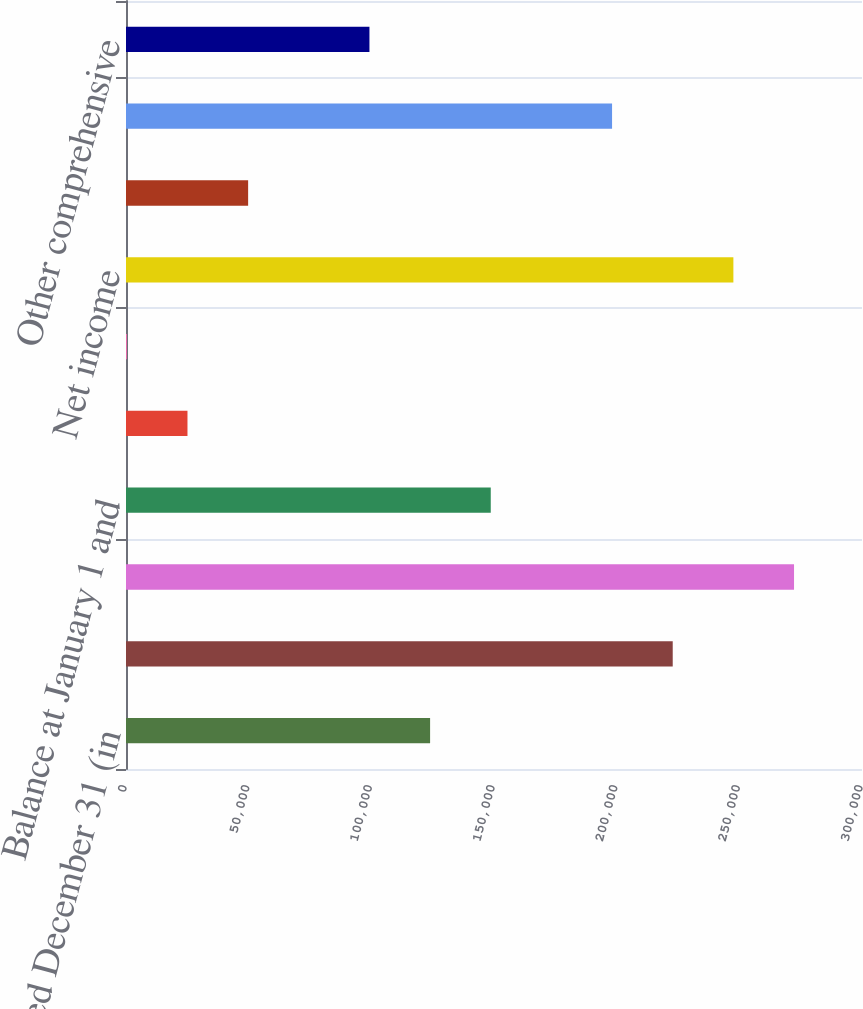<chart> <loc_0><loc_0><loc_500><loc_500><bar_chart><fcel>Year ended December 31 (in<fcel>Balance at January 1<fcel>Balance at December 31<fcel>Balance at January 1 and<fcel>Shares issued and commitments<fcel>Other<fcel>Net income<fcel>Preferred stock<fcel>Common stock ( 188 172 and 158<fcel>Other comprehensive<nl><fcel>123954<fcel>222849<fcel>272297<fcel>148677<fcel>25057.9<fcel>334<fcel>247573<fcel>49781.8<fcel>198125<fcel>99229.6<nl></chart> 